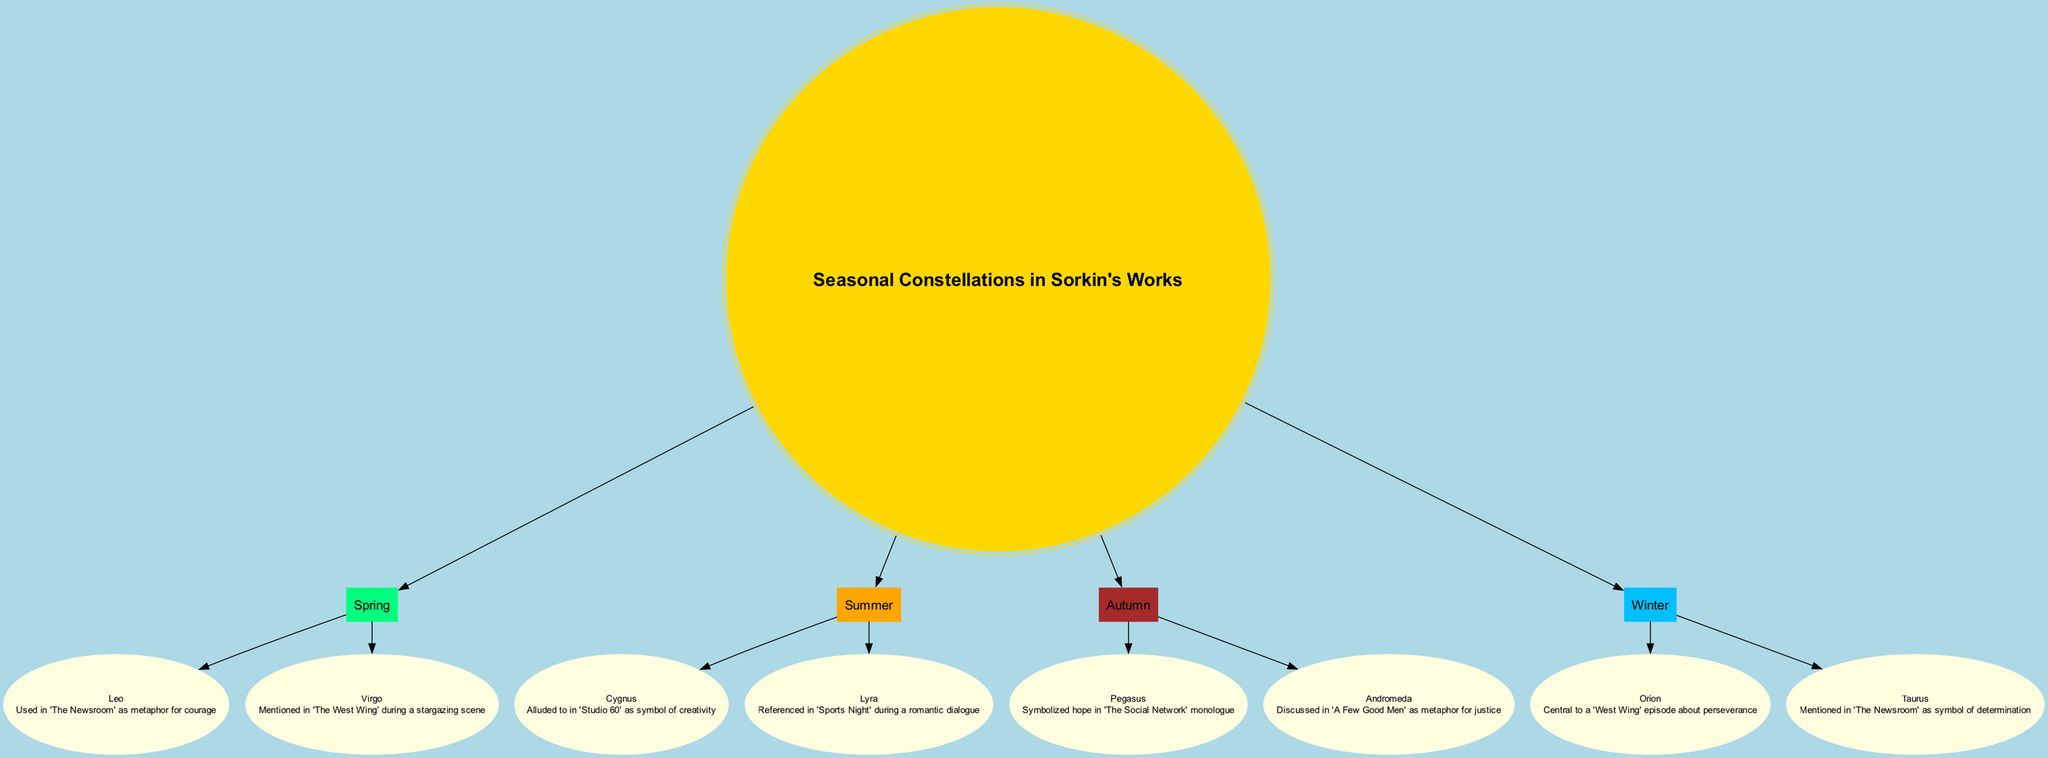What are the constellations visible in Spring? According to the diagram, the constellations visible in Spring are Leo and Virgo. This information can be found directly in the section associated with the Spring node, where each constellation is listed.
Answer: Leo, Virgo Which constellation is associated with hope? The diagram connects the constellation Pegasus with hope as it is described in the reference associated with Pegasus under the Autumn season. This involves recognizing the label and reference text linked to that constellation.
Answer: Pegasus How many constellations are shown in the Summer season? Within the Summer section of the diagram, there are two constellations: Cygnus and Lyra. Counting them gives the total of two.
Answer: 2 In which Sorkin show is Orion referenced? Orion is mentioned in 'The West Wing' within the context of a discussion centered on perseverance. This reference can be found directly under the Orion constellation in the Winter section.
Answer: The West Wing Which season includes Virgo? The diagram indicates that Virgo is found under the Spring section. By following the connections from the center node to the season nodes and then to the constellation, the season can be identified.
Answer: Spring What does the constellation Lyra symbolize? The diagram refers to Lyra in the context of a romantic dialogue in 'Sports Night'. By examining the connection between the Summer season and the Lyra constellation, this meaning can be extracted.
Answer: Creativity 